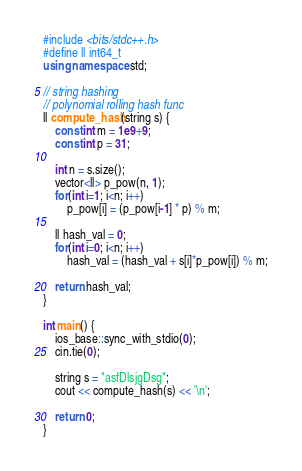<code> <loc_0><loc_0><loc_500><loc_500><_C++_>#include <bits/stdc++.h>
#define ll int64_t
using namespace std;

// string hashing
// polynomial rolling hash func 
ll compute_hash(string s) {
    const int m = 1e9+9;
    const int p = 31;

    int n = s.size();
    vector<ll> p_pow(n, 1);
    for(int i=1; i<n; i++)
        p_pow[i] = (p_pow[i-1] * p) % m;

    ll hash_val = 0;
    for(int i=0; i<n; i++) 
        hash_val = (hash_val + s[i]*p_pow[i]) % m;

    return hash_val;
}

int main() {
    ios_base::sync_with_stdio(0);
    cin.tie(0);
    
    string s = "asfDlsjgDsg";
    cout << compute_hash(s) << '\n';
    
    return 0;
}</code> 